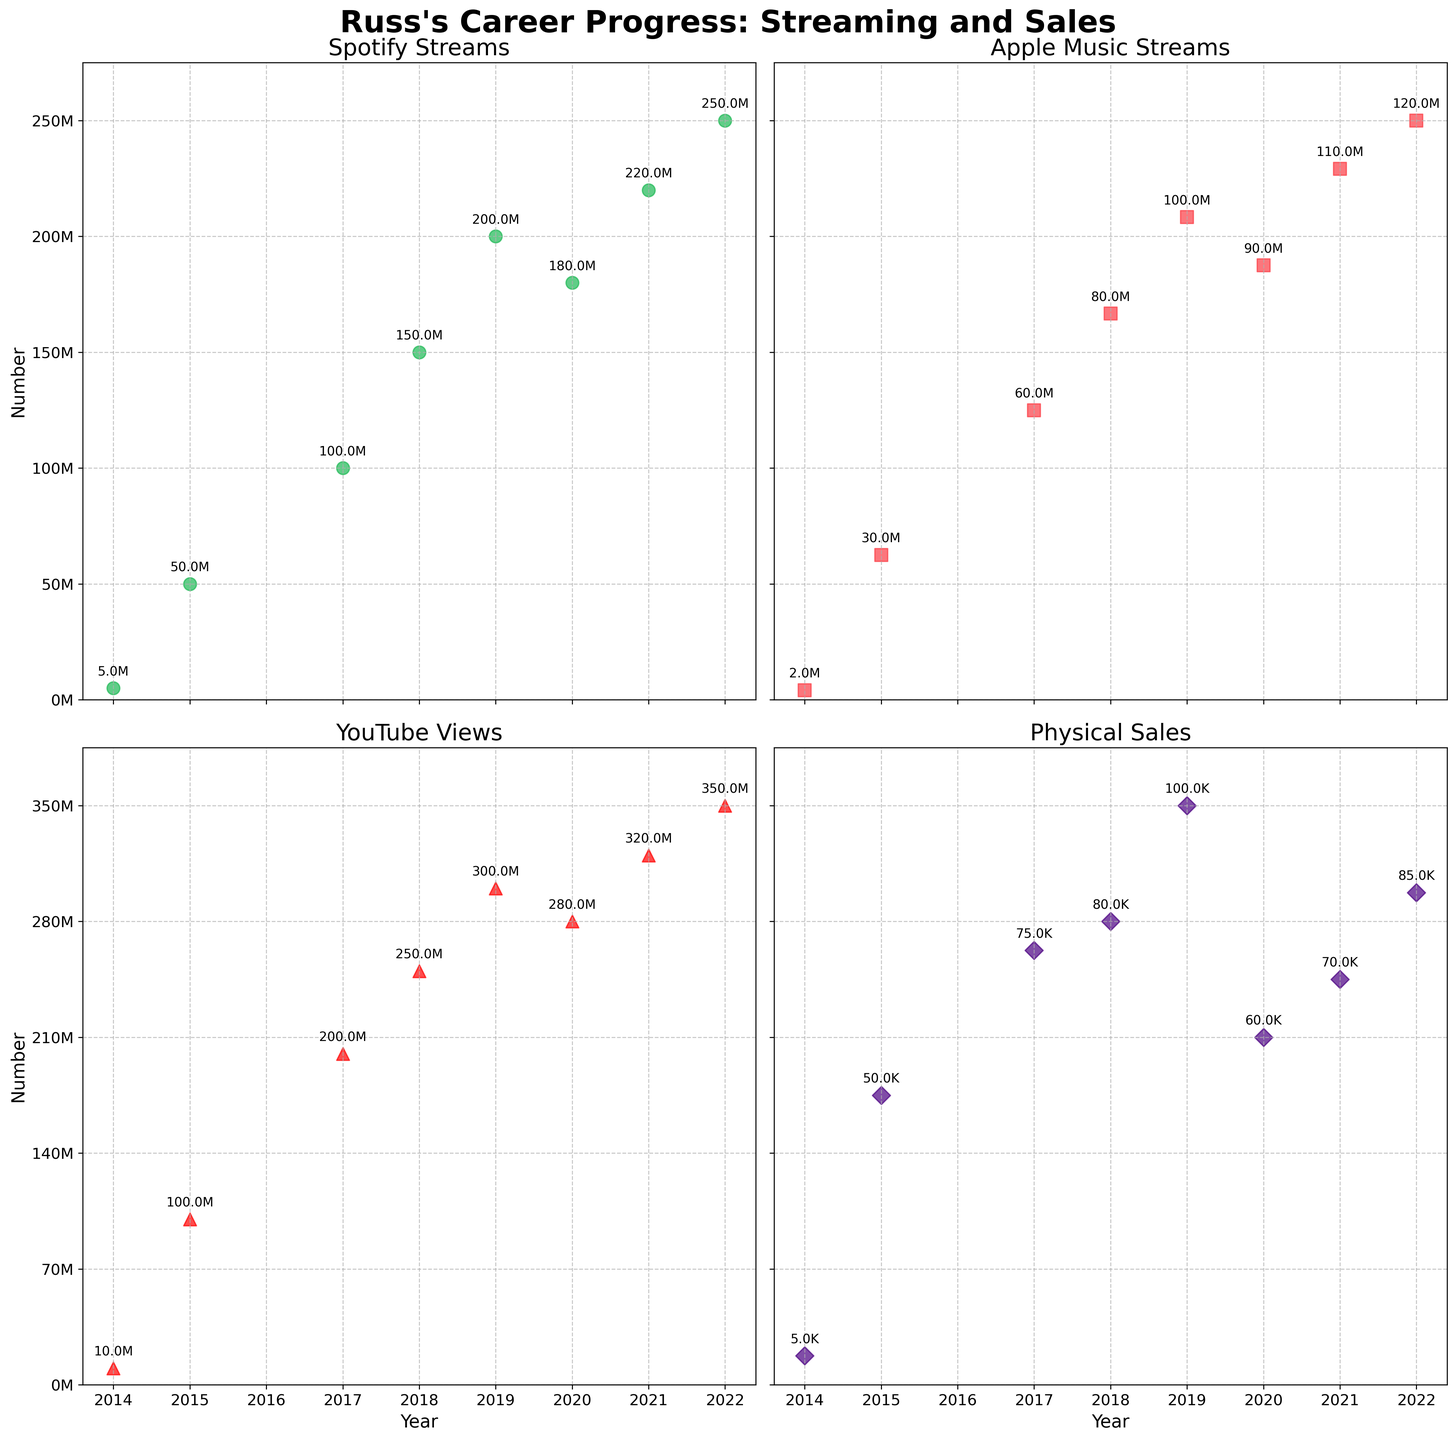What's the title of the figure? The title of the figure is written at the top.
Answer: Russ's Career Progress: Streaming and Sales How many subplots are there in the figure? The figure consists of multiple smaller plots arranged in a grid. Each subplot corresponds to a different platform or metric.
Answer: 4 Which platform had the highest streaming numbers in 2022? Looking at the scatter plots, identify the highest point for the year 2022 on each subplot. Compare these points to determine the platform with the highest numbers.
Answer: Spotify What is the trend for Russ's physical sales from 2014 to 2022? Examine the scatter plot for physical sales, observing how the points change over the years. Note the pattern of increase or decrease.
Answer: Increasing Does YouTube have higher views compared to Spotify streams in 2017? Look at the data points for both YouTube Views and Spotify Streams in the year 2017 and compare the values. YouTube views for 2017 are higher.
Answer: Yes What is the difference in Apple Music streams between 2018 and 2020? Check the scatter points for Apple Music Streams for the years 2018 and 2020, then subtract the 2018 value from the 2020 value to find the difference. Apple Music streams were 80 million in 2018 and 90 million in 2020. The difference is 10 million.
Answer: 10 million Compare the trend of Spotify streams and physical sales between 2018 and 2022. Look at the scatter plots for Spotify Streams and Physical Sales from 2018 to 2022, observe the pattern of increase or decrease for each platform, and compare these trends. Both Spotify streams and physical sales show an increasing trend over this period.
Answer: Both increased Which year experienced the highest growth in Spotify streams compared to the previous year? Calculate the differences in Spotify Streams between consecutive years and identify the year with the maximum increase.
Answer: 2017 How many albums were released between 2014 and 2022? Count the number of data points in any of the scatter plots, which correspond to the number of albums released during the given time frame.
Answer: 8 What's the percentage increase in YouTube views from 2014 to 2017? Find the YouTube views for 2014 and 2017, calculate the difference, and then compute the percentage increase using the formula [(2017 value - 2014 value) / 2014 value] * 100. YouTube views were 10 million in 2014 and 200 million in 2017. The difference is 190 million. The percentage increase is (190/10)*100 = 1900%.
Answer: 1900% 